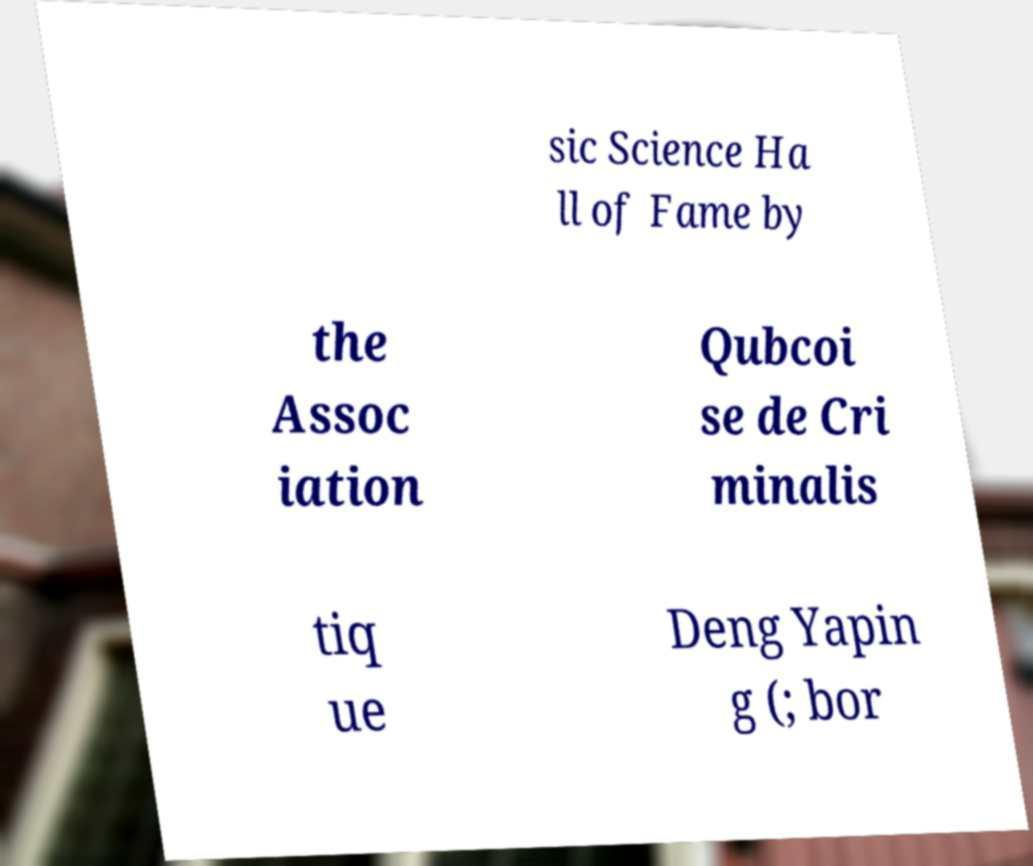I need the written content from this picture converted into text. Can you do that? sic Science Ha ll of Fame by the Assoc iation Qubcoi se de Cri minalis tiq ue Deng Yapin g (; bor 